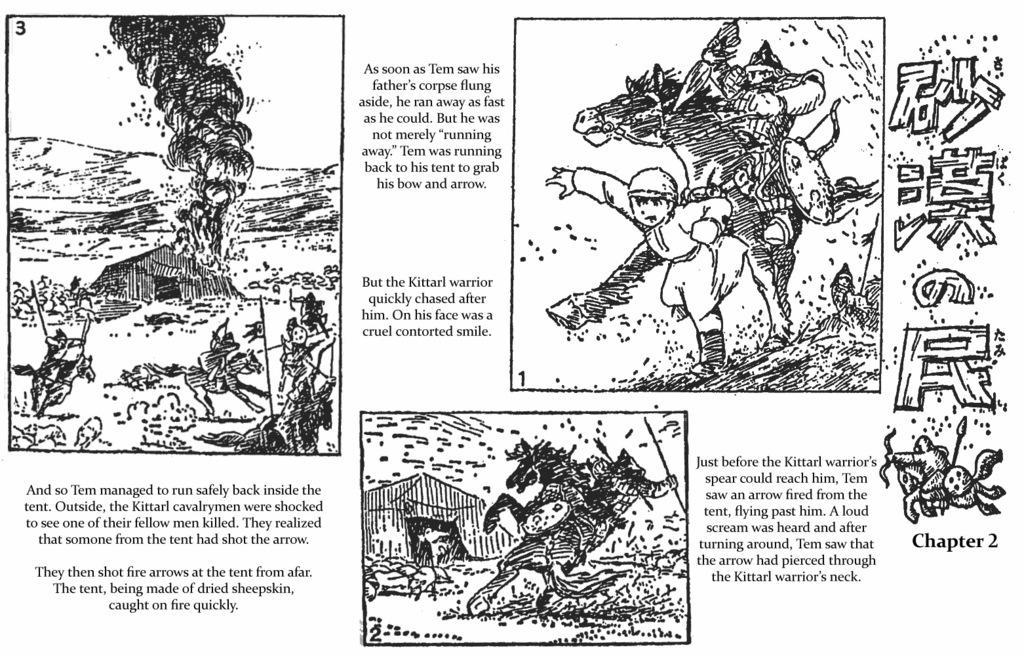Can you describe this image briefly? In this image there are few paintings of few pictures and there is some text. Left side there is a house. Before it few persons are sitting on the horses. Right side there is a person running. Behind him there is a person sitting on the horse. Bottom of the image there is a horse, beside there is a tent. There is some text beside the painting. 